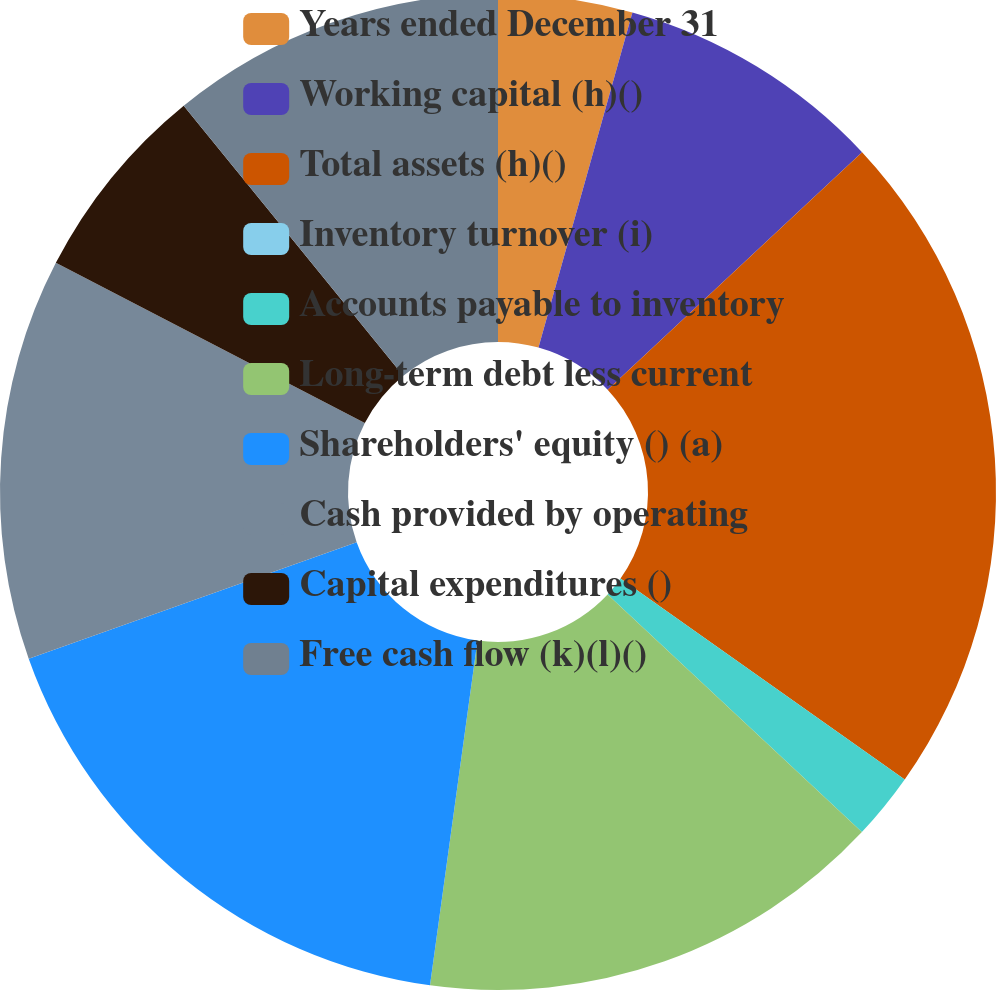Convert chart. <chart><loc_0><loc_0><loc_500><loc_500><pie_chart><fcel>Years ended December 31<fcel>Working capital (h)()<fcel>Total assets (h)()<fcel>Inventory turnover (i)<fcel>Accounts payable to inventory<fcel>Long-term debt less current<fcel>Shareholders' equity () (a)<fcel>Cash provided by operating<fcel>Capital expenditures ()<fcel>Free cash flow (k)(l)()<nl><fcel>4.35%<fcel>8.7%<fcel>21.74%<fcel>0.0%<fcel>2.17%<fcel>15.22%<fcel>17.39%<fcel>13.04%<fcel>6.52%<fcel>10.87%<nl></chart> 